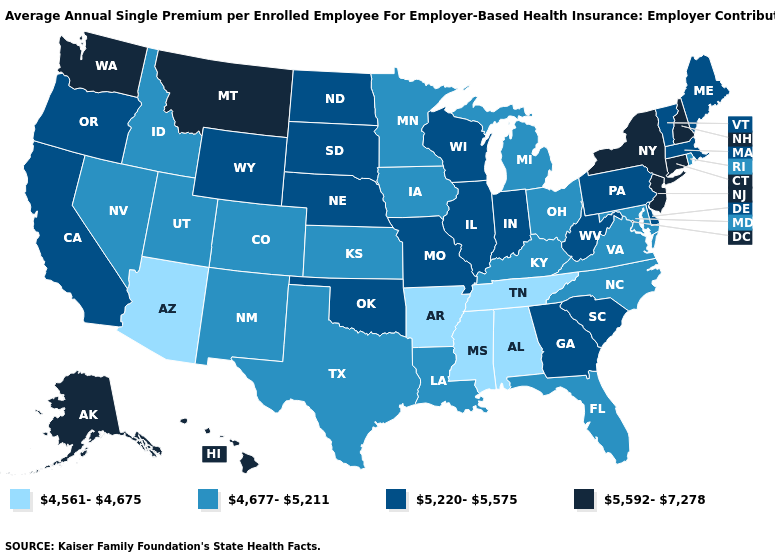What is the value of North Dakota?
Be succinct. 5,220-5,575. Which states have the lowest value in the MidWest?
Quick response, please. Iowa, Kansas, Michigan, Minnesota, Ohio. Which states have the highest value in the USA?
Short answer required. Alaska, Connecticut, Hawaii, Montana, New Hampshire, New Jersey, New York, Washington. Name the states that have a value in the range 5,220-5,575?
Concise answer only. California, Delaware, Georgia, Illinois, Indiana, Maine, Massachusetts, Missouri, Nebraska, North Dakota, Oklahoma, Oregon, Pennsylvania, South Carolina, South Dakota, Vermont, West Virginia, Wisconsin, Wyoming. Among the states that border Arizona , does Nevada have the lowest value?
Write a very short answer. Yes. Which states have the lowest value in the USA?
Quick response, please. Alabama, Arizona, Arkansas, Mississippi, Tennessee. Does South Carolina have a higher value than Nebraska?
Answer briefly. No. What is the highest value in the Northeast ?
Answer briefly. 5,592-7,278. Does Arizona have the lowest value in the West?
Write a very short answer. Yes. Does Arkansas have the lowest value in the USA?
Give a very brief answer. Yes. Does Pennsylvania have the highest value in the USA?
Keep it brief. No. Which states have the lowest value in the USA?
Short answer required. Alabama, Arizona, Arkansas, Mississippi, Tennessee. Among the states that border Georgia , does Alabama have the lowest value?
Keep it brief. Yes. What is the lowest value in states that border Wyoming?
Be succinct. 4,677-5,211. Does Alabama have the lowest value in the USA?
Concise answer only. Yes. 